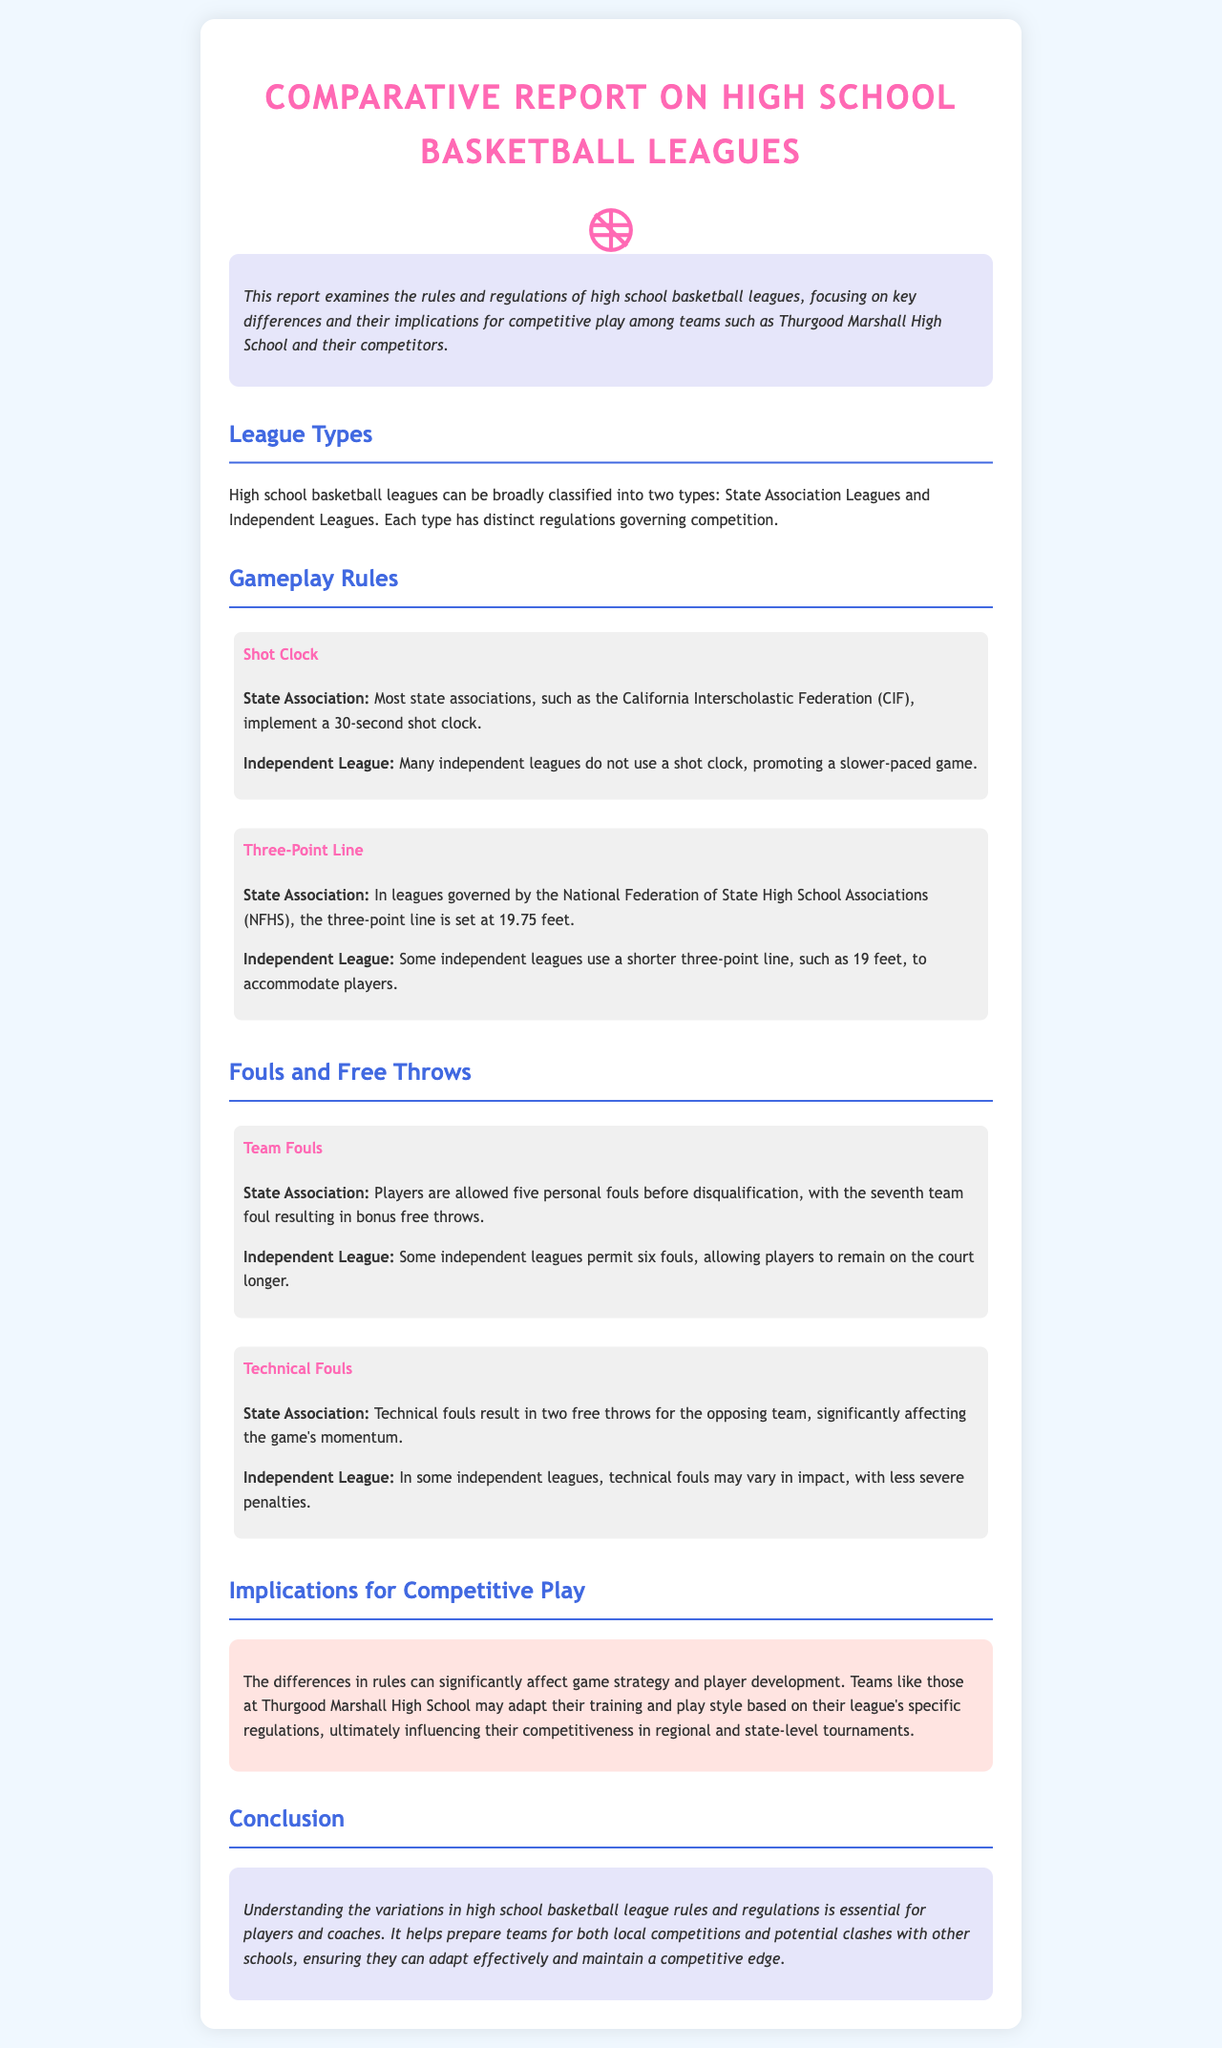What are the two types of high school basketball leagues? The document mentions State Association Leagues and Independent Leagues as the two classifications of high school basketball leagues.
Answer: State Association Leagues and Independent Leagues What is the shot clock duration in State Association leagues? The State Association leagues implement a 30-second shot clock, as stated in the gameplay rules section.
Answer: 30 seconds What is the distance of the three-point line in NFHS governed leagues? The three-point line in leagues governed by the National Federation of State High School Associations (NFHS) is set at 19.75 feet according to the rules mentioned.
Answer: 19.75 feet How many personal fouls does a player get before disqualification in State Association leagues? Players in State Association leagues are allowed five personal fouls before disqualification, as described in the fouls and free throws section.
Answer: Five What happens when a technical foul is called in State Association leagues? In State Association leagues, a technical foul results in two free throws for the opposing team, which significantly impacts game momentum as noted in the fouls section.
Answer: Two free throws How do rules affect game strategy according to the implications section? The differences in rules affect game strategy and player development, which is highlighted in the implications for competitive play.
Answer: Affect game strategy and player development What is the purpose of understanding variations in league rules? Understanding these variations helps prepare teams for local competitions and clashes with other schools, as mentioned in the conclusion section.
Answer: To prepare teams for competitions Which league may allow a shorter three-point line? The document indicates that some independent leagues use a shorter three-point line than the NFHS standard, based on the gameplay rules comparison.
Answer: Independent Leagues 